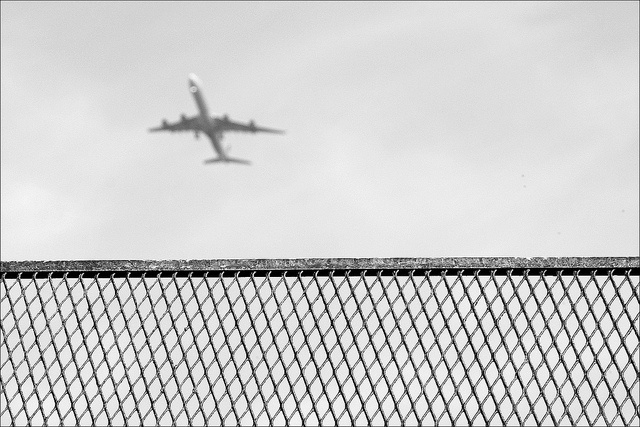Describe the objects in this image and their specific colors. I can see a airplane in darkgray, gray, lightgray, black, and dimgray tones in this image. 